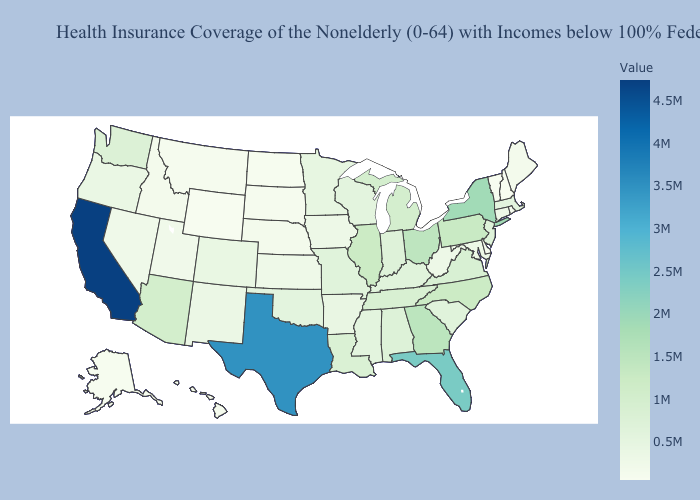Among the states that border Vermont , does New York have the lowest value?
Quick response, please. No. Does California have the highest value in the West?
Concise answer only. Yes. Which states hav the highest value in the South?
Short answer required. Texas. Which states hav the highest value in the Northeast?
Write a very short answer. New York. Does Nevada have the highest value in the West?
Be succinct. No. 